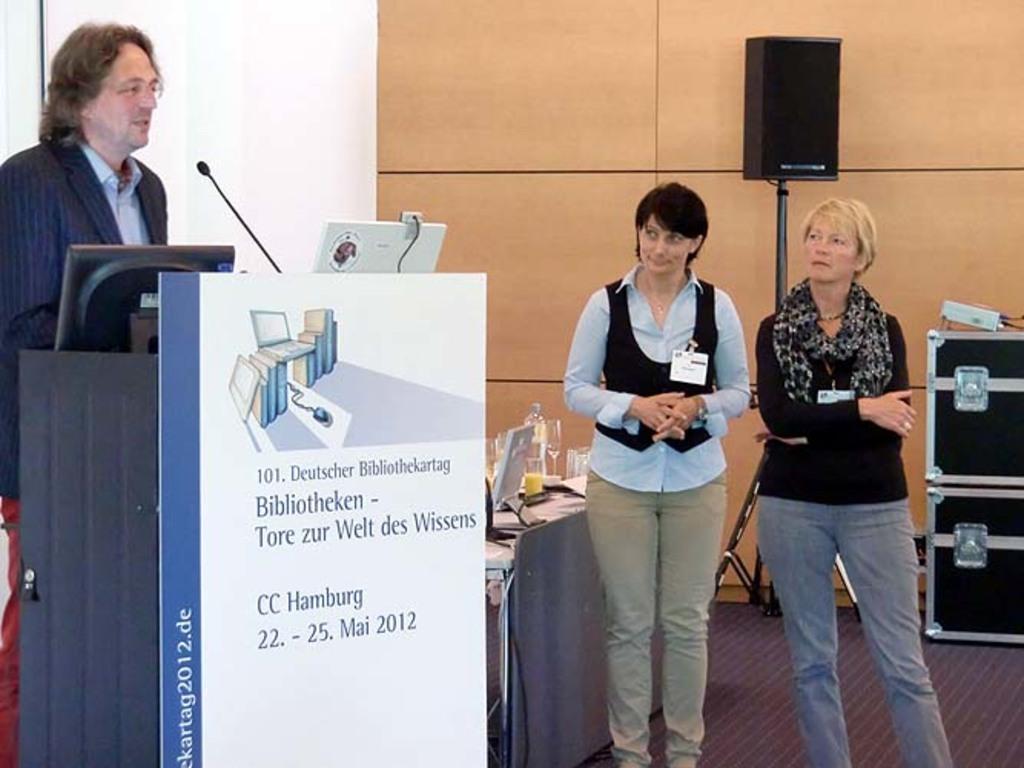How would you summarize this image in a sentence or two? Here in this picture on the left side we can see a person standing over a place and in front of him we can see a speech desk present with microphone on it over there and we can see he is speaking something in the microphone over there and we can also see a monitor and a laptop in front of him and we can also see a banner present in front of the speech desk and beside him we can see two women with ID cards on them standing on the floor over there and behind them we can see a table, on which we can see a monitor and bottles, glasses present over there and we can also see speaker present on the stand over there. 